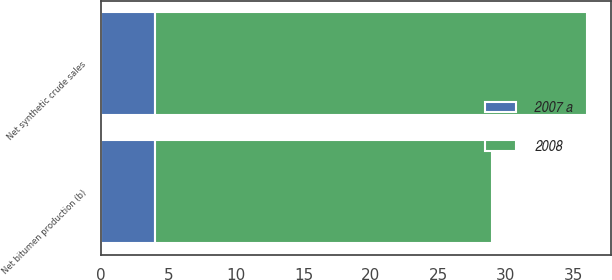Convert chart to OTSL. <chart><loc_0><loc_0><loc_500><loc_500><stacked_bar_chart><ecel><fcel>Net bitumen production (b)<fcel>Net synthetic crude sales<nl><fcel>2008<fcel>25<fcel>32<nl><fcel>2007 a<fcel>4<fcel>4<nl></chart> 